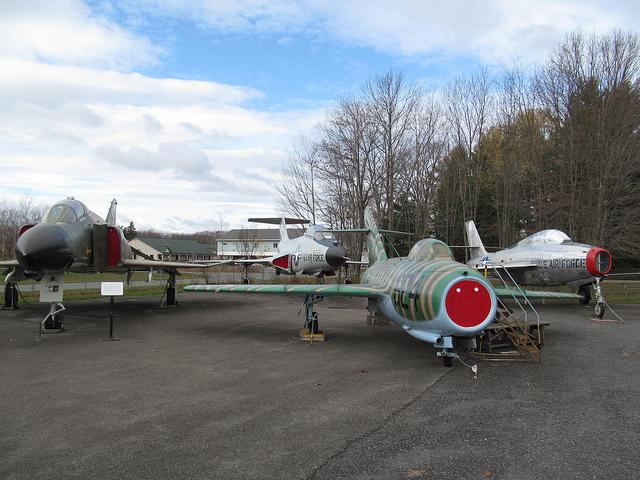The planes were likely used for what transportation purpose? Please explain your reasoning. military. They are small planes that can only seat one or 2 people, which resemble those of fighter jets used in the wars. 